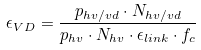Convert formula to latex. <formula><loc_0><loc_0><loc_500><loc_500>\epsilon _ { V D } = \frac { p _ { h v / v d } \cdot N _ { h v / v d } } { p _ { h v } \cdot N _ { h v } \cdot \epsilon _ { l i n k } \cdot f _ { c } }</formula> 